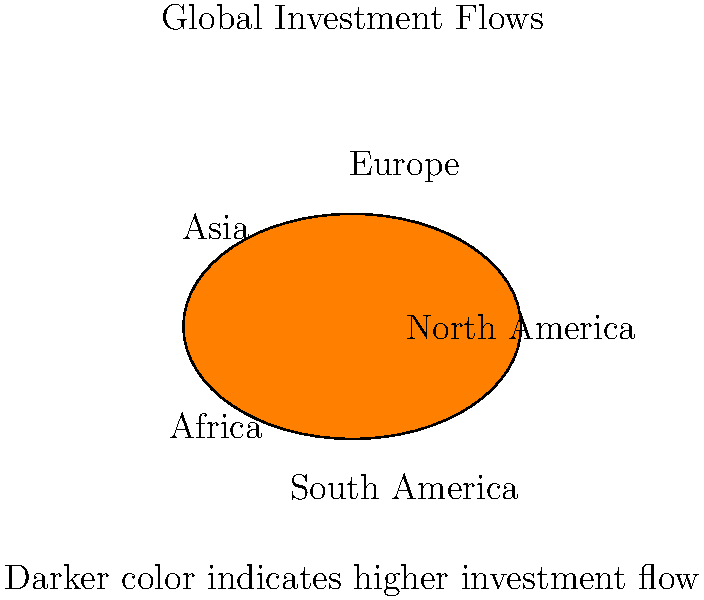Based on the color-coded world map showing global investment flows, which region appears to have the highest level of investment, and what implications might this have for global economic dynamics? To answer this question, we need to analyze the color-coded map and interpret its implications:

1. Color intensity analysis:
   - The map uses color intensity to represent investment flows.
   - Darker or more saturated colors indicate higher investment levels.

2. Regional comparison:
   - North America: Red (moderately dark)
   - Europe: Green (darkest color)
   - Asia: Blue (light color)
   - Africa: Yellow (lightest color)
   - South America: Orange (moderate color)

3. Identifying highest investment flow:
   - Europe has the darkest green color, indicating the highest level of investment flow.

4. Implications for global economic dynamics:
   a) Capital concentration: High investment in Europe suggests a concentration of capital, potentially leading to faster economic growth and development in this region.
   
   b) Economic power shift: This could indicate a shift or maintenance of economic power towards Europe, possibly influencing global economic policies and trade negotiations.
   
   c) Market maturity: High investment flows might suggest that investors perceive European markets as stable and mature, offering reliable returns.
   
   d) Potential for inequality: The disparity in investment flows could lead to widening economic gaps between regions, particularly between Europe and Africa.
   
   e) Opportunities in underinvested regions: Lower investment flows in regions like Africa and Asia might present untapped opportunities for future growth and higher returns.

5. Considering alternative factors:
   - It's important to note that investment flows alone don't provide a complete picture of economic health or potential. Factors such as market saturation, economic cycles, and geopolitical events also play crucial roles in determining long-term economic dynamics.
Answer: Europe; potential for increased economic power and global influence, but may exacerbate regional economic disparities. 